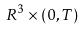<formula> <loc_0><loc_0><loc_500><loc_500>R ^ { 3 } \times ( 0 , T )</formula> 